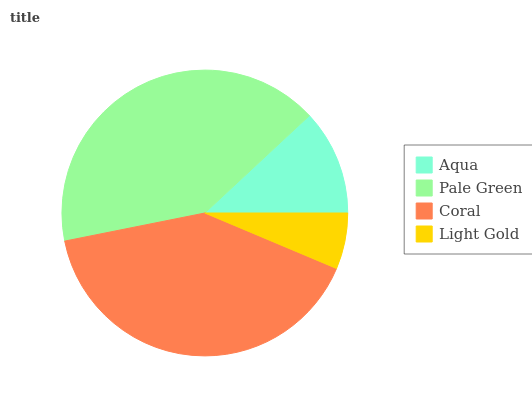Is Light Gold the minimum?
Answer yes or no. Yes. Is Pale Green the maximum?
Answer yes or no. Yes. Is Coral the minimum?
Answer yes or no. No. Is Coral the maximum?
Answer yes or no. No. Is Pale Green greater than Coral?
Answer yes or no. Yes. Is Coral less than Pale Green?
Answer yes or no. Yes. Is Coral greater than Pale Green?
Answer yes or no. No. Is Pale Green less than Coral?
Answer yes or no. No. Is Coral the high median?
Answer yes or no. Yes. Is Aqua the low median?
Answer yes or no. Yes. Is Light Gold the high median?
Answer yes or no. No. Is Pale Green the low median?
Answer yes or no. No. 